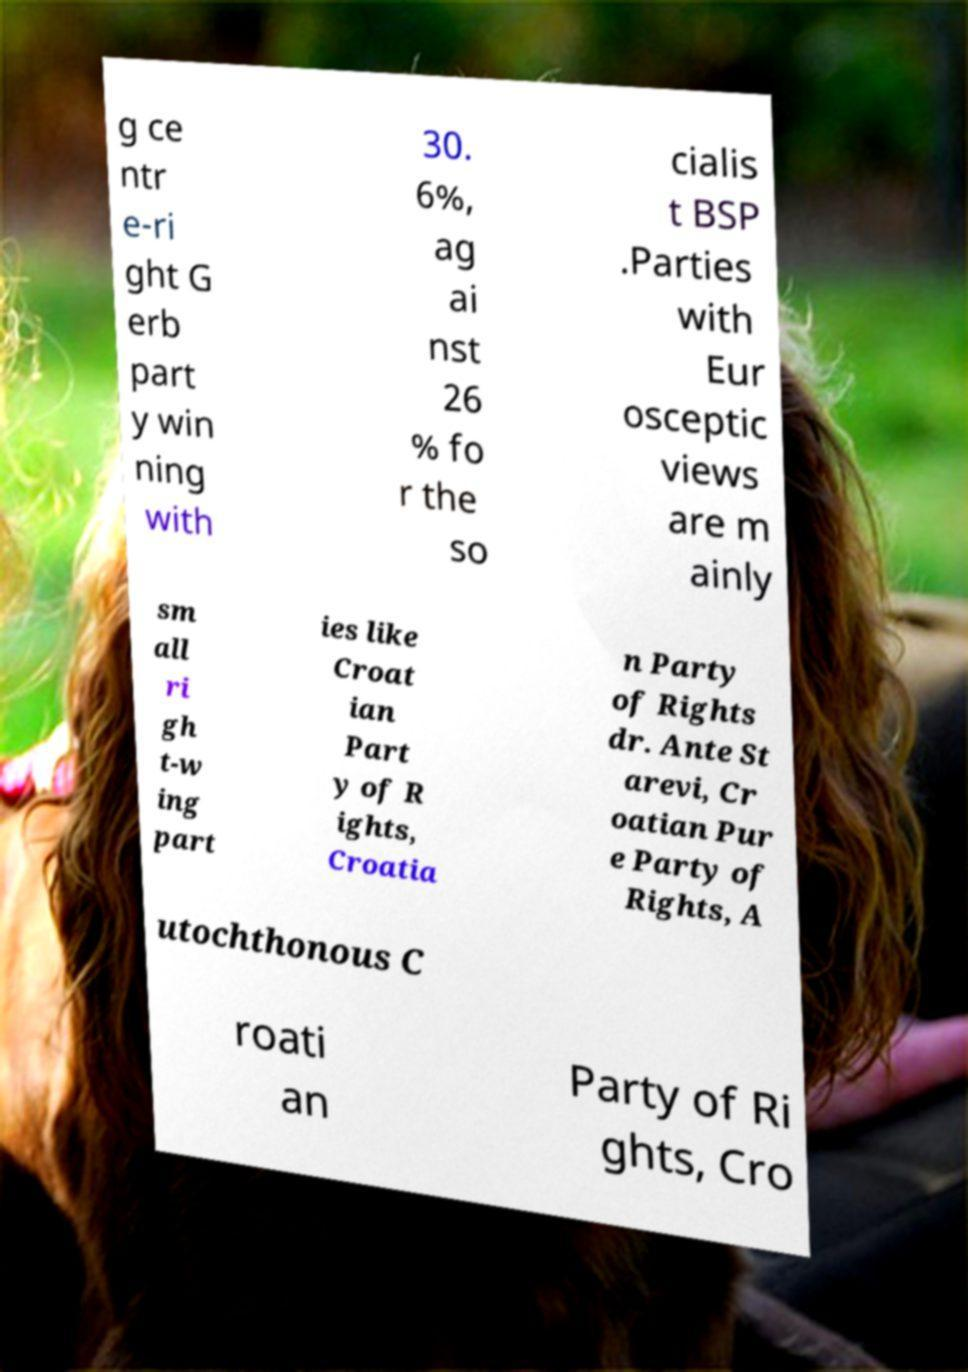There's text embedded in this image that I need extracted. Can you transcribe it verbatim? g ce ntr e-ri ght G erb part y win ning with 30. 6%, ag ai nst 26 % fo r the so cialis t BSP .Parties with Eur osceptic views are m ainly sm all ri gh t-w ing part ies like Croat ian Part y of R ights, Croatia n Party of Rights dr. Ante St arevi, Cr oatian Pur e Party of Rights, A utochthonous C roati an Party of Ri ghts, Cro 